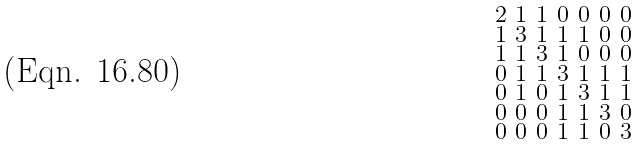Convert formula to latex. <formula><loc_0><loc_0><loc_500><loc_500>\begin{smallmatrix} 2 & 1 & 1 & 0 & 0 & 0 & 0 \\ 1 & 3 & 1 & 1 & 1 & 0 & 0 \\ 1 & 1 & 3 & 1 & 0 & 0 & 0 \\ 0 & 1 & 1 & 3 & 1 & 1 & 1 \\ 0 & 1 & 0 & 1 & 3 & 1 & 1 \\ 0 & 0 & 0 & 1 & 1 & 3 & 0 \\ 0 & 0 & 0 & 1 & 1 & 0 & 3 \end{smallmatrix}</formula> 